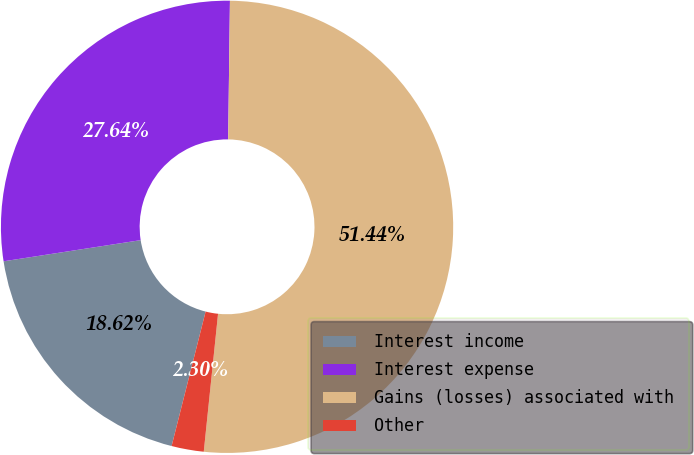<chart> <loc_0><loc_0><loc_500><loc_500><pie_chart><fcel>Interest income<fcel>Interest expense<fcel>Gains (losses) associated with<fcel>Other<nl><fcel>18.62%<fcel>27.64%<fcel>51.44%<fcel>2.3%<nl></chart> 